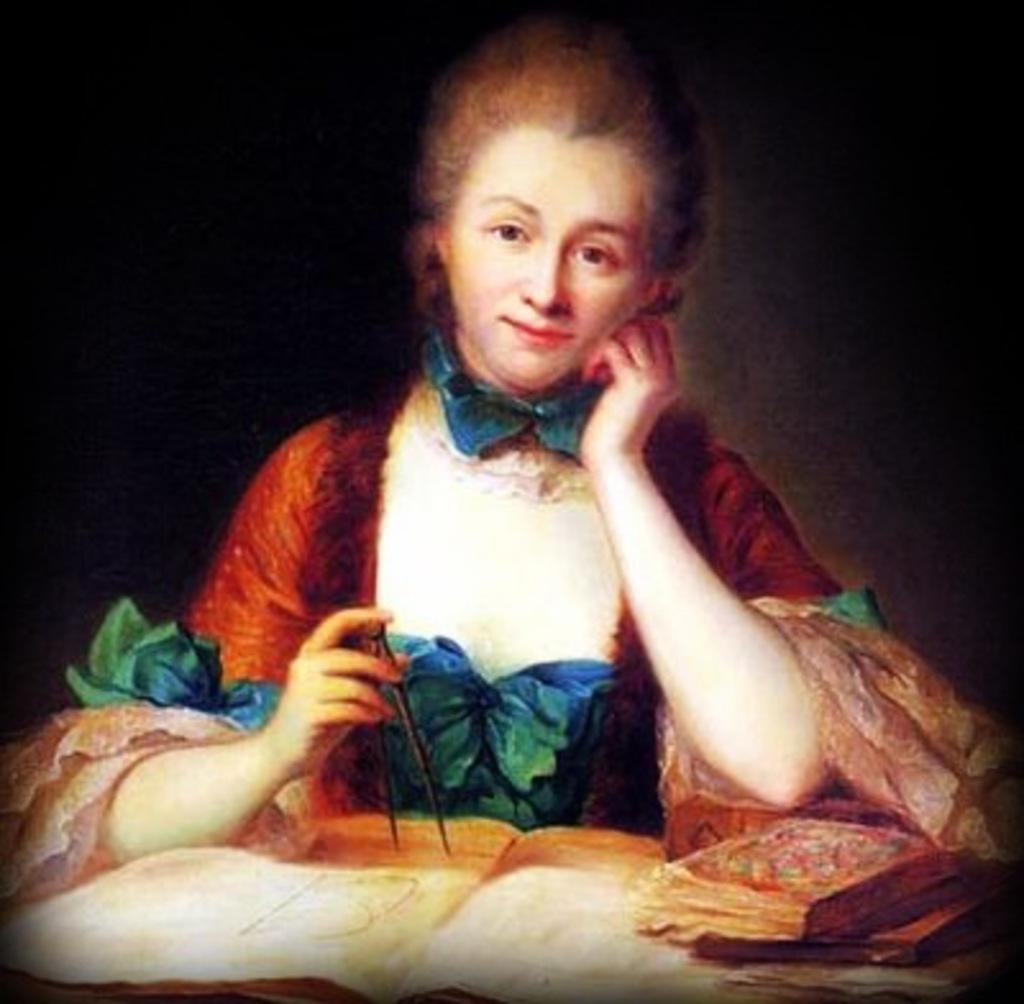How would you summarize this image in a sentence or two? Here we can see woman holding an object,in front of this woman we can see books. In the background it is dark. 